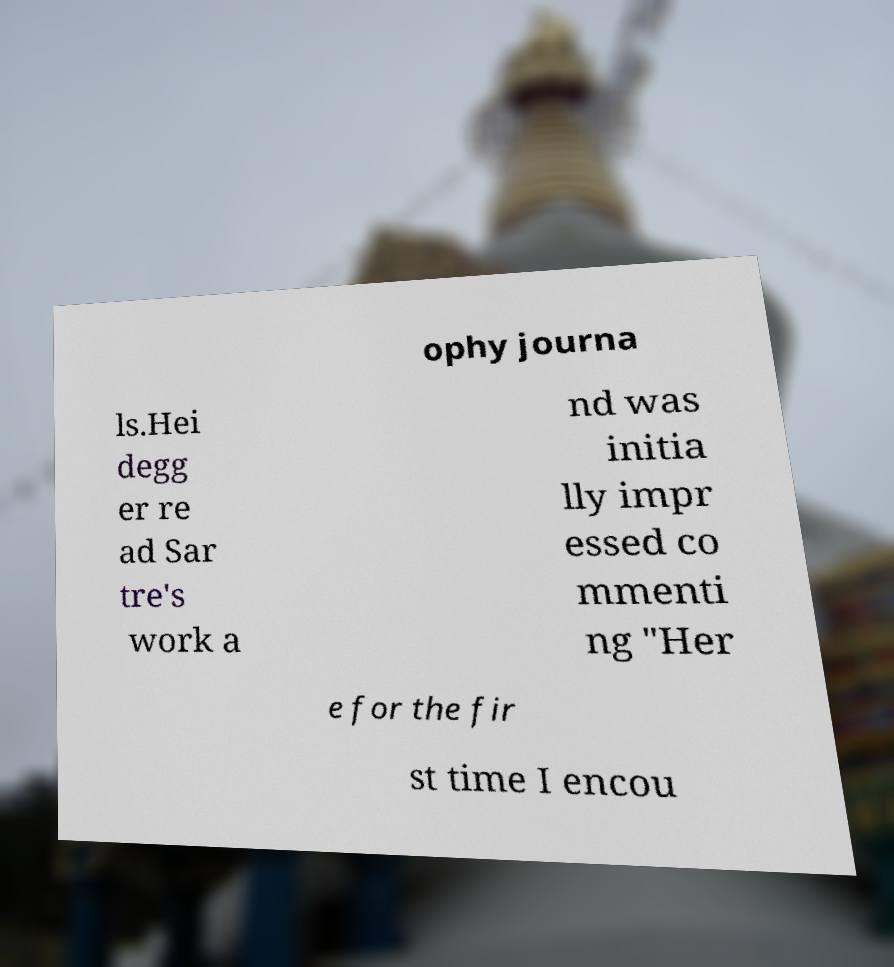For documentation purposes, I need the text within this image transcribed. Could you provide that? ophy journa ls.Hei degg er re ad Sar tre's work a nd was initia lly impr essed co mmenti ng "Her e for the fir st time I encou 